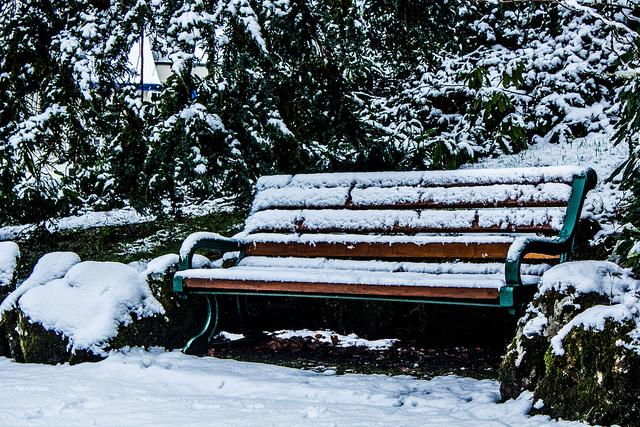Is the snow deep?
Quick response, please. No. Is the area warm?
Keep it brief. No. Are there people outside?
Write a very short answer. No. 